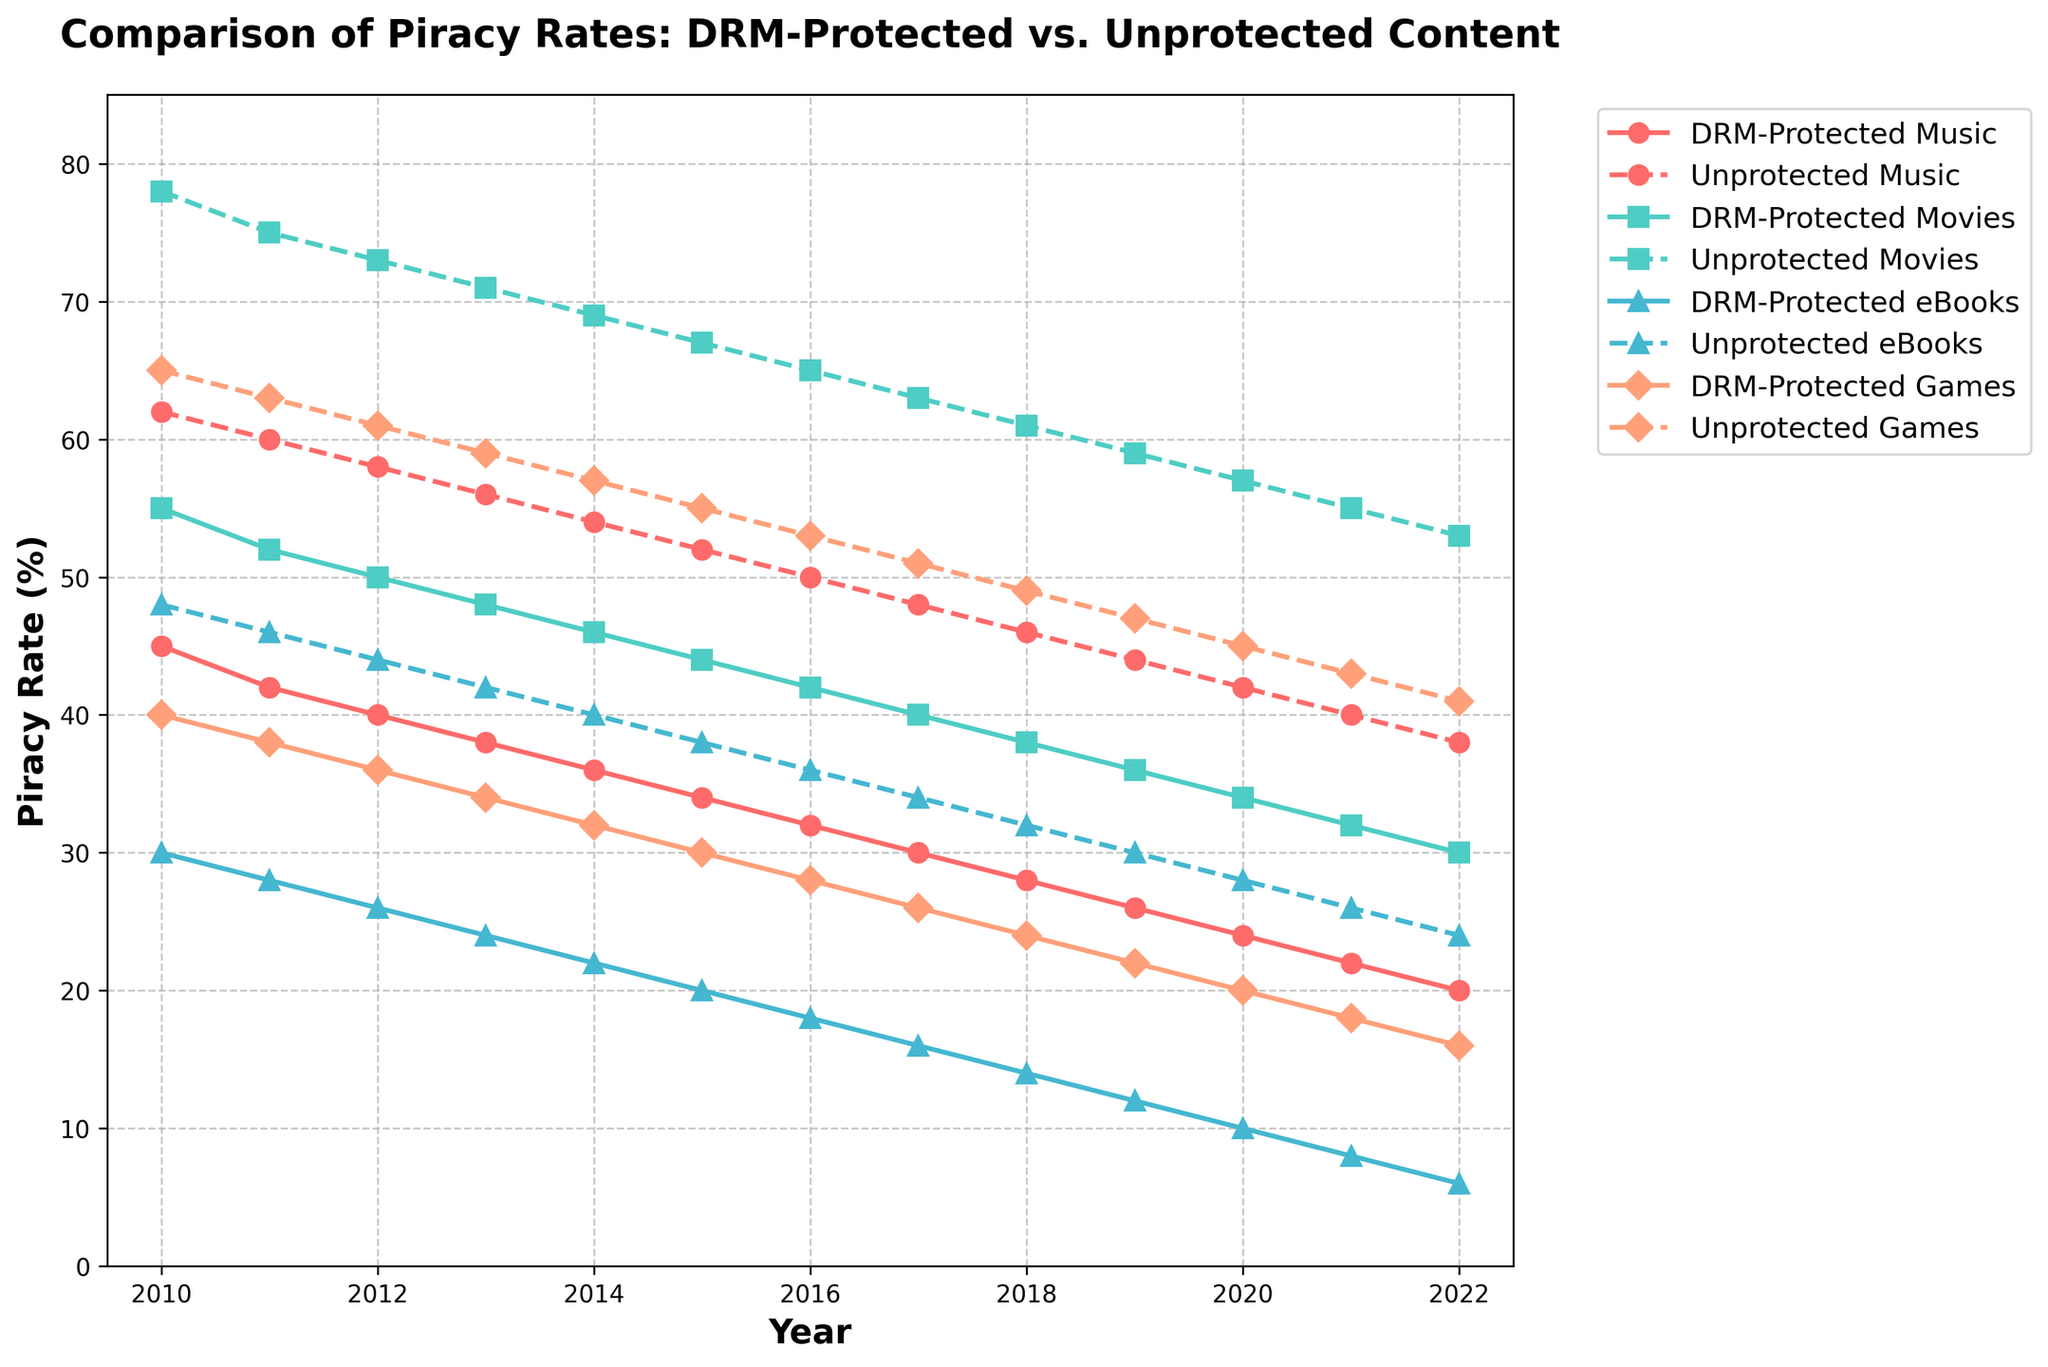What trend do we see in the piracy rates for DRM-protected Music from 2010 to 2022? The piracy rates for DRM-protected Music show a consistent decreasing trend from 45% in 2010 to 20% in 2022.
Answer: Decreasing trend Which media type had the highest piracy rate for unprotected content in 2010? The highest piracy rate for unprotected content in 2010 was Movies at 78%.
Answer: Movies By how much did the piracy rate for DRM-protected eBooks decrease between 2010 and 2022? The piracy rate for DRM-protected eBooks decreased from 30% in 2010 to 6% in 2022, a difference of 24%.
Answer: 24% How does the piracy rate for unprotected Games in 2022 compare to that of DRM-protected Games in the same year? In 2022, the piracy rate for unprotected Games was 41%, while for DRM-protected games it was 16%. The rate for unprotected Games is higher by 25%.
Answer: Higher by 25% Which media type shows the largest difference in piracy rates between DRM-protected and unprotected content in 2012? In 2012, Movies show the largest difference with unprotected Movies at 73% and DRM-protected Movies at 50%, a difference of 23%.
Answer: Movies What is the average piracy rate for DRM-protected content across all media types in 2022? For DRM-protected content in 2022, the rates are 20% (Music), 30% (Movies), 6% (eBooks), and 16% (Games). The average is (20 + 30 + 6 + 16) / 4 = 18%.
Answer: 18% Between which consecutive years did unprotected Movies see the most significant drop in piracy rates? The most significant drop in piracy rates for unprotected Movies occurred between 2012 (73%) and 2013 (71%), a decrease of 2%.
Answer: 2012-2013 Compare the trends for DRM-protected and unprotected eBooks from 2010 to 2022. Both DRM-protected and unprotected eBooks show a decreasing trend from 2010 to 2022. DRM-protected eBooks went from 30% to 6%, while unprotected eBooks went from 48% to 24%.
Answer: Both decreasing Which year had the closest piracy rates between DRM-protected and unprotected Music? In 2022, the piracy rates for DRM-protected Music (20%) and unprotected Music (38%) had a difference of 18%, the smallest margin compared to other years.
Answer: 2022 What color represents the piracy rate trend for DRM-protected Movies in the chart? The color representing DRM-protected Movies is green.
Answer: Green 